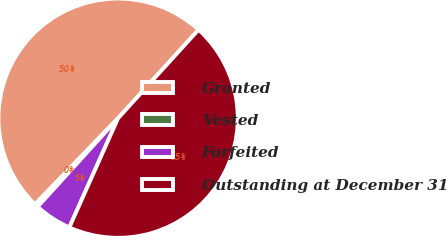Convert chart. <chart><loc_0><loc_0><loc_500><loc_500><pie_chart><fcel>Granted<fcel>Vested<fcel>Forfeited<fcel>Outstanding at December 31<nl><fcel>49.53%<fcel>0.47%<fcel>5.06%<fcel>44.94%<nl></chart> 